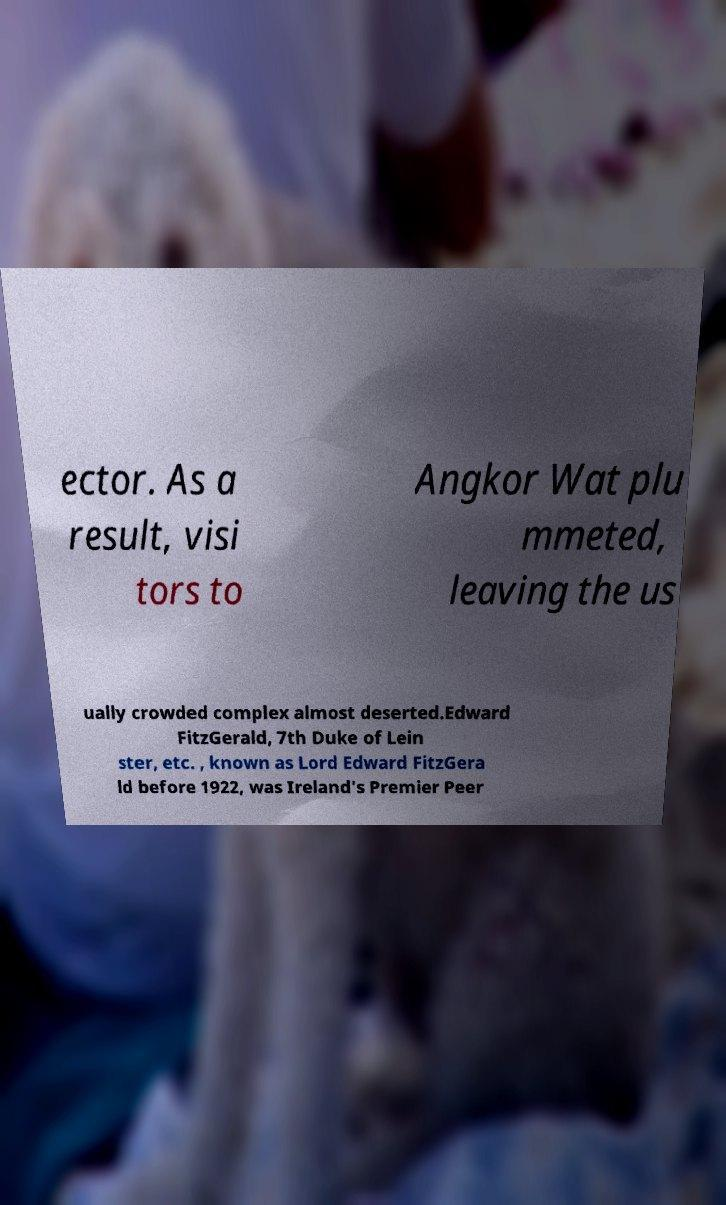There's text embedded in this image that I need extracted. Can you transcribe it verbatim? ector. As a result, visi tors to Angkor Wat plu mmeted, leaving the us ually crowded complex almost deserted.Edward FitzGerald, 7th Duke of Lein ster, etc. , known as Lord Edward FitzGera ld before 1922, was Ireland's Premier Peer 